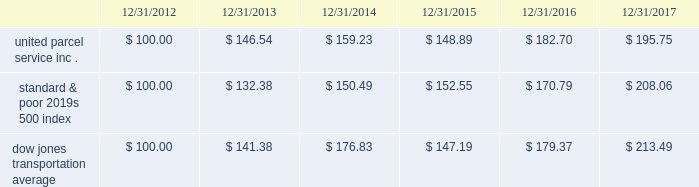Shareowner return performance graph the following performance graph and related information shall not be deemed 201csoliciting material 201d or to be 201cfiled 201d with the sec , nor shall such information be incorporated by reference into any future filing under the securities act of 1933 or securities exchange act of 1934 , each as amended , except to the extent that the company specifically incorporates such information by reference into such filing .
The following graph shows a five-year comparison of cumulative total shareowners 2019 returns for our class b common stock , the standard & poor 2019s 500 index and the dow jones transportation average .
The comparison of the total cumulative return on investment , which is the change in the quarterly stock price plus reinvested dividends for each of the quarterly periods , assumes that $ 100 was invested on december 31 , 2012 in the standard & poor 2019s 500 index , the dow jones transportation average and our class b common stock. .

What is the difference in percentage cumulative total shareowners return for united parcel service inc . versus the dow jones transportation average for the five years ended 12/31/2017? 
Computations: (((195.75 - 100) / 100) - ((213.49 - 100) / 100))
Answer: -0.1774. 